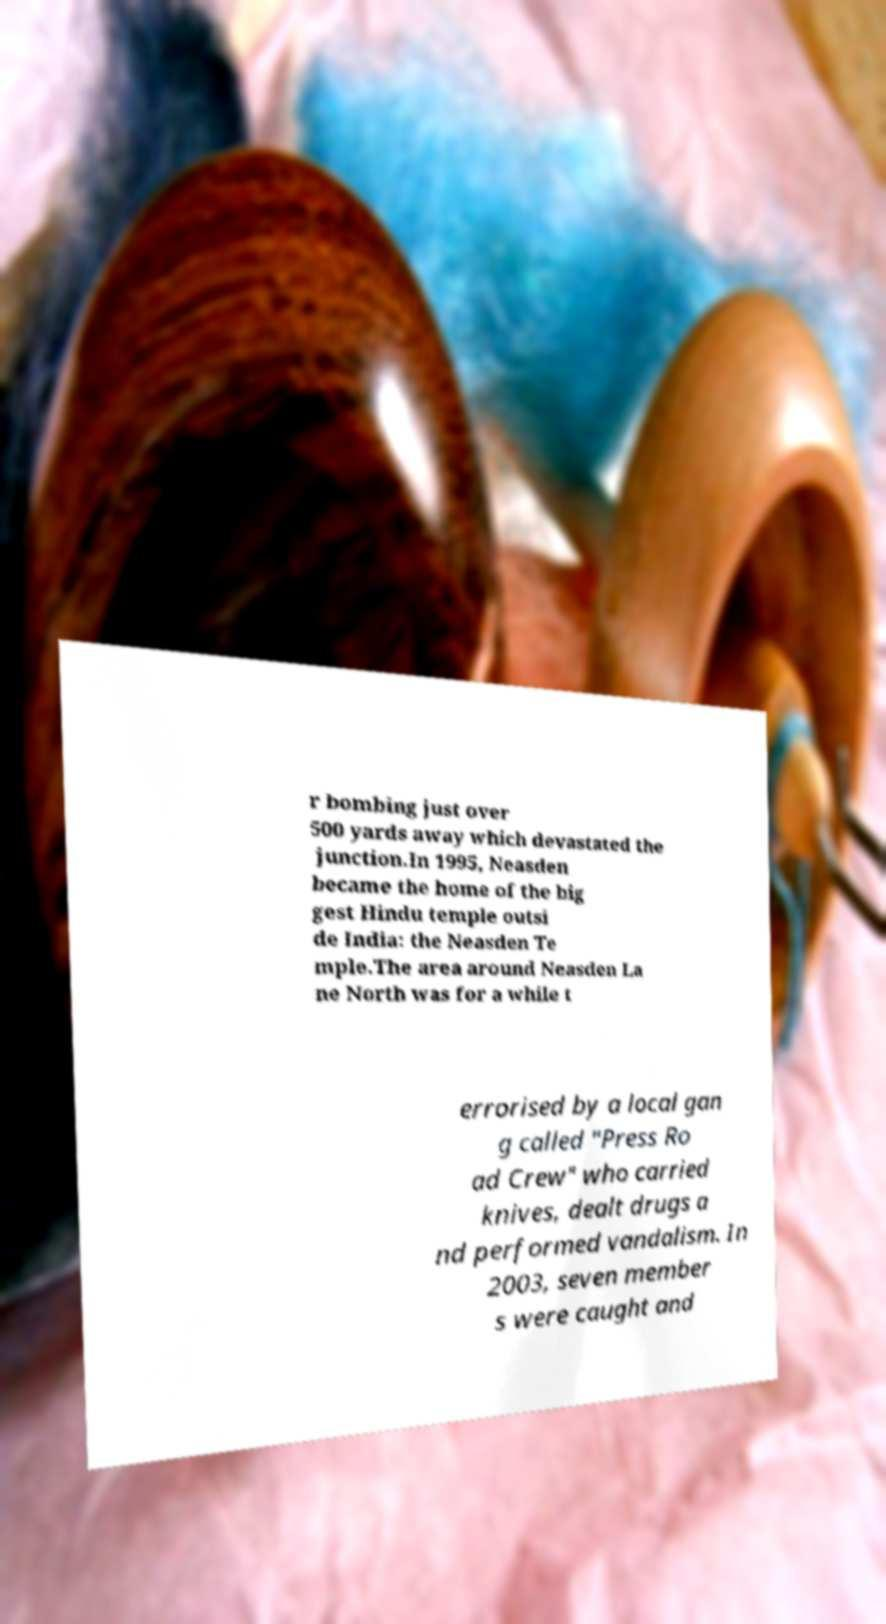What messages or text are displayed in this image? I need them in a readable, typed format. r bombing just over 500 yards away which devastated the junction.In 1995, Neasden became the home of the big gest Hindu temple outsi de India: the Neasden Te mple.The area around Neasden La ne North was for a while t errorised by a local gan g called "Press Ro ad Crew" who carried knives, dealt drugs a nd performed vandalism. In 2003, seven member s were caught and 